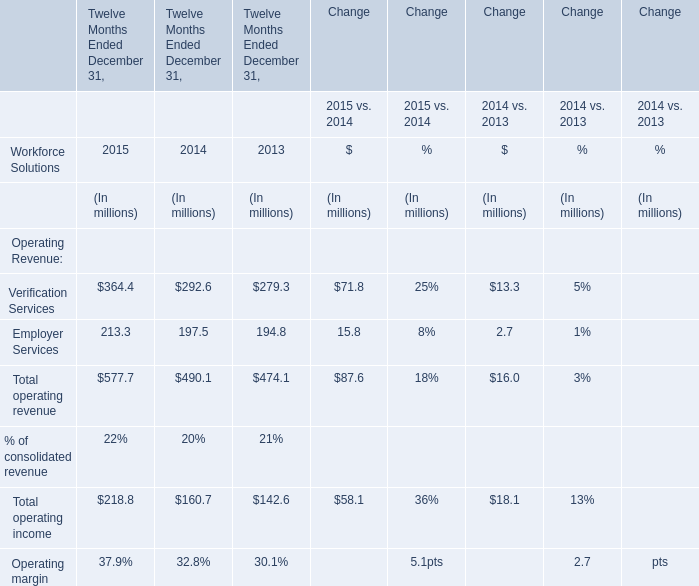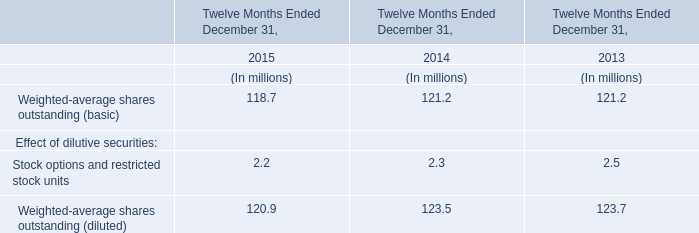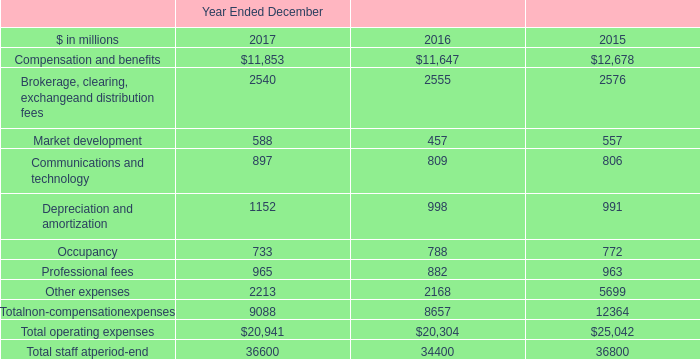What was the total amount of Operating Revenue excluding those Operating Revenue greater than 300 in 2015? (in million) 
Answer: 213.3. 